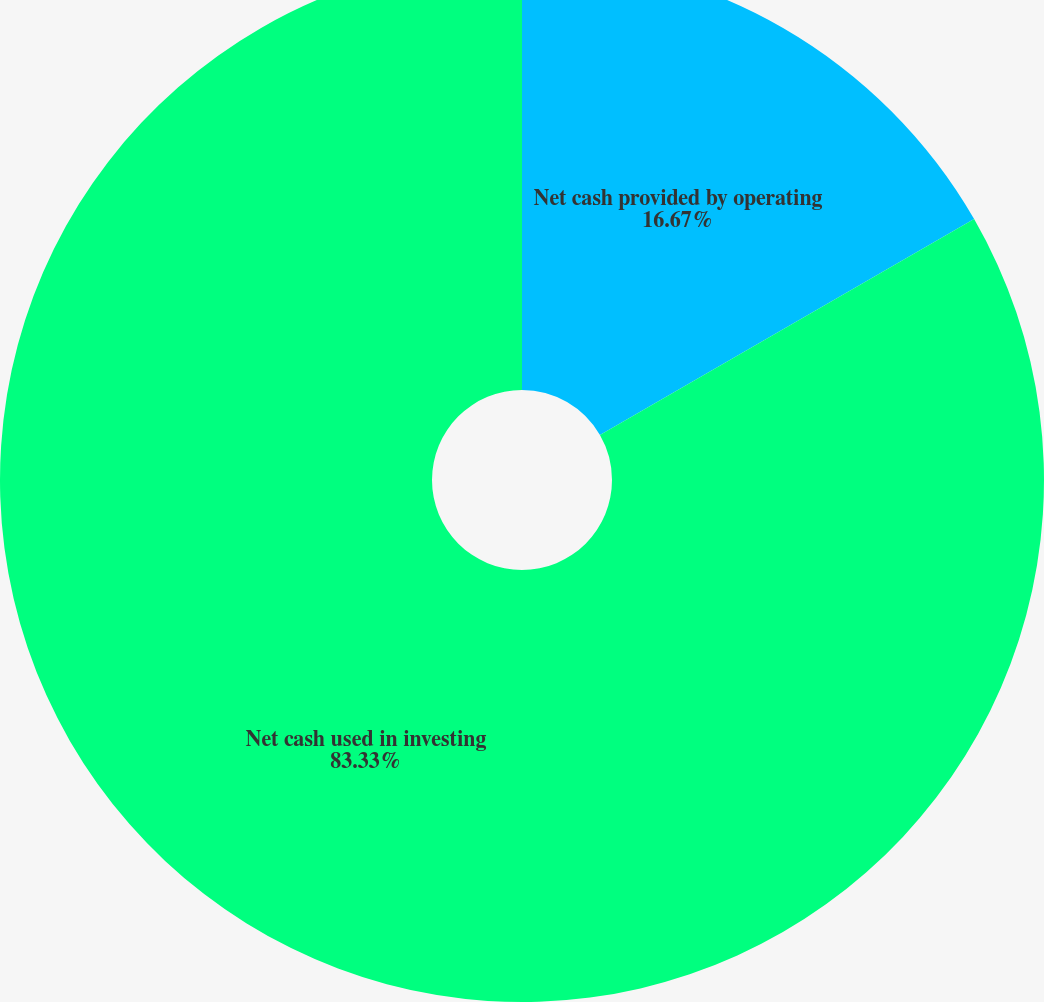<chart> <loc_0><loc_0><loc_500><loc_500><pie_chart><fcel>Net cash provided by operating<fcel>Net cash used in investing<nl><fcel>16.67%<fcel>83.33%<nl></chart> 